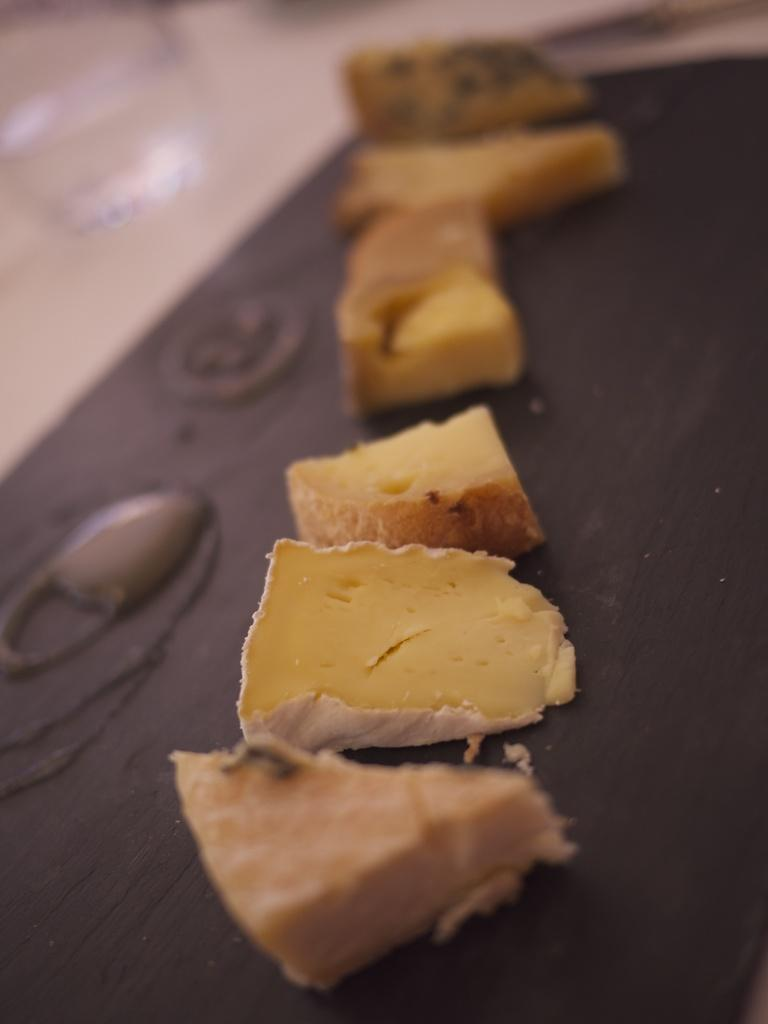What type of food can be seen on the table in the image? There are cheese slices on the table. How many cheese slices are visible in the image? The number of cheese slices is not specified, but there are at least some visible on the table. What might someone be about to do with the cheese slices? Someone might be about to use the cheese slices for a sandwich, snack, or meal. What is the chance of the cheese slices winning a race in the image? There is no race or competition involving cheese slices in the image, so it's not possible to determine their chances of winning. 